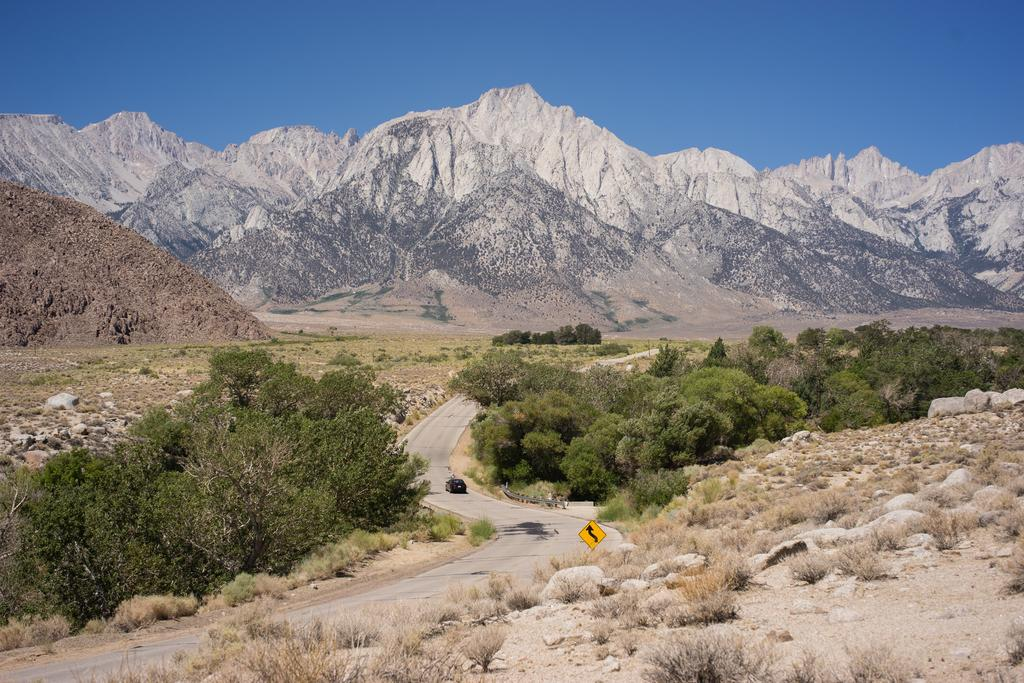Where was the image taken? The image was clicked outside the city. What is in the center of the image? There is a vehicle running on the road in the center of the image. What type of natural elements can be seen in the image? There are trees and plants visible in the image. What can be seen in the background of the image? There is a sky and hills visible in the background of the image. How many cakes are placed on the vehicle in the image? There are no cakes present in the image; it features a vehicle running on the road outside the city. What type of toys can be seen scattered around the trees in the image? There are no toys visible in the image; it only shows trees and plants. 